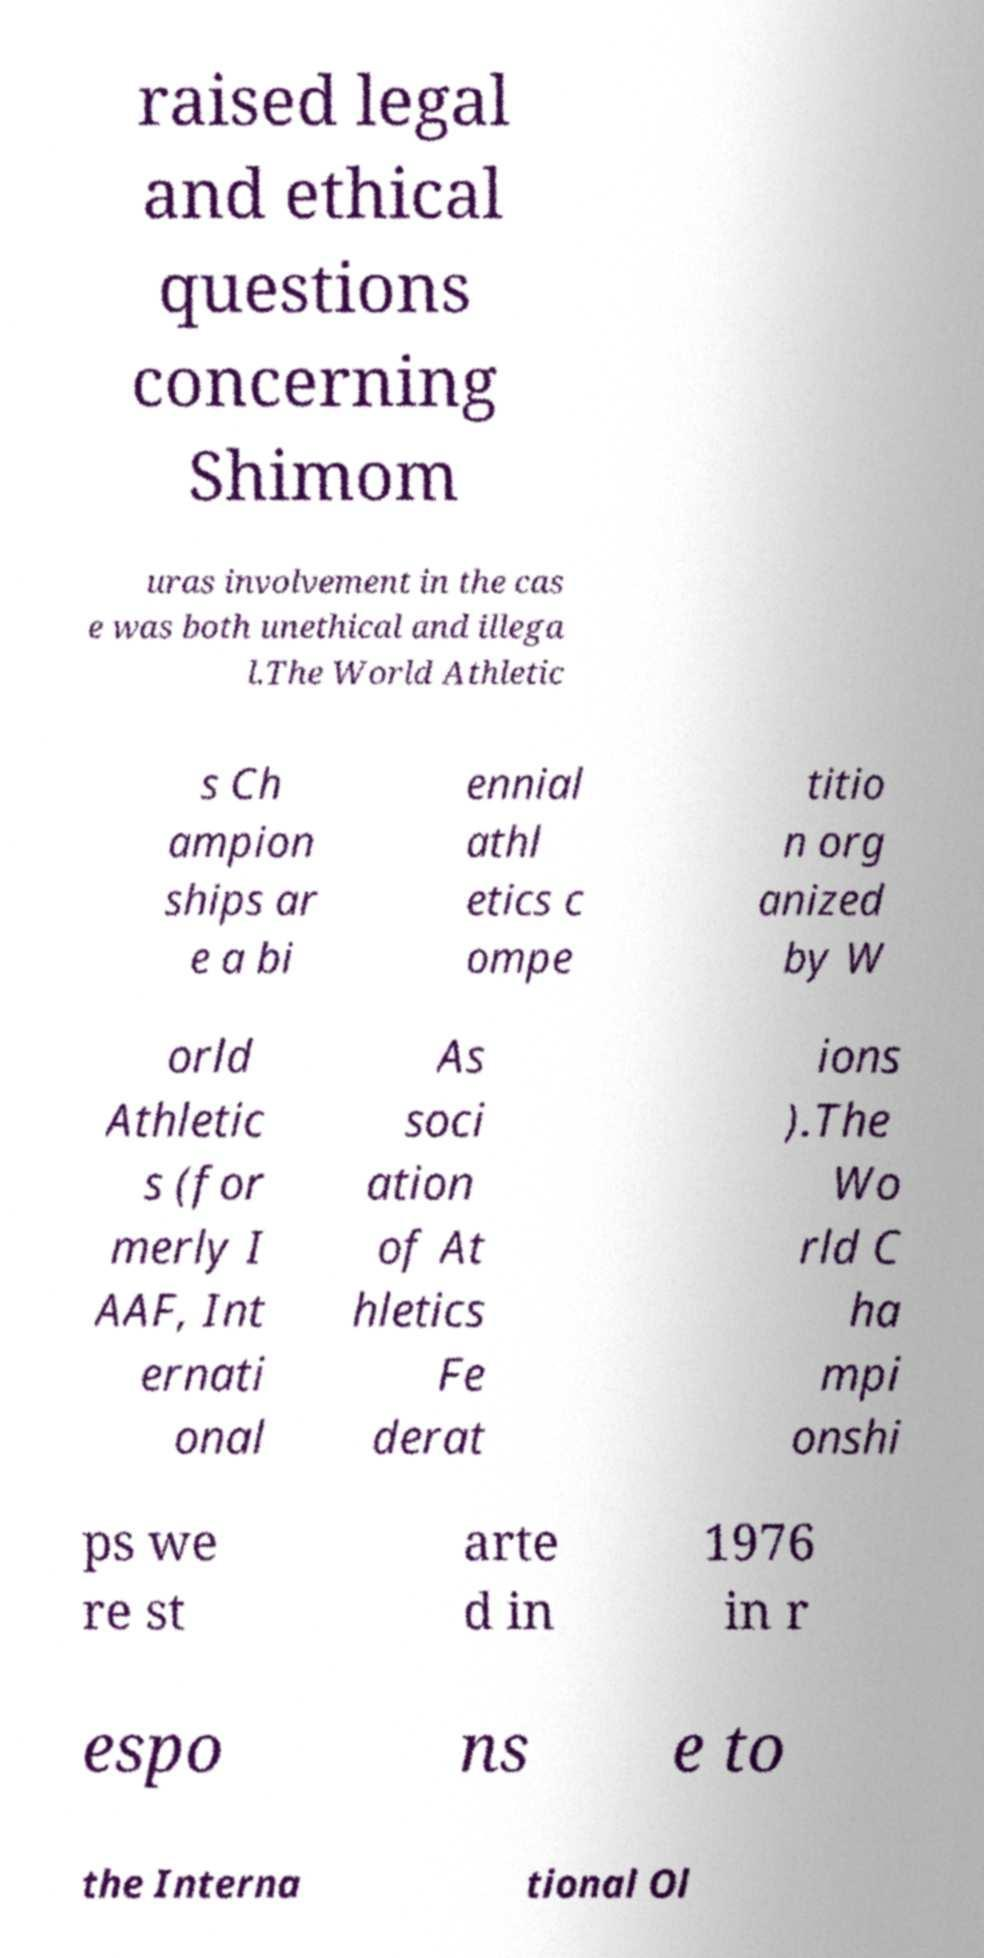There's text embedded in this image that I need extracted. Can you transcribe it verbatim? raised legal and ethical questions concerning Shimom uras involvement in the cas e was both unethical and illega l.The World Athletic s Ch ampion ships ar e a bi ennial athl etics c ompe titio n org anized by W orld Athletic s (for merly I AAF, Int ernati onal As soci ation of At hletics Fe derat ions ).The Wo rld C ha mpi onshi ps we re st arte d in 1976 in r espo ns e to the Interna tional Ol 